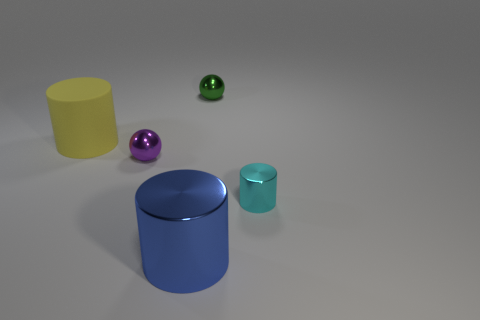Subtract all large cylinders. How many cylinders are left? 1 Add 2 large blue metallic things. How many objects exist? 7 Subtract all spheres. How many objects are left? 3 Subtract all yellow balls. Subtract all small green metallic balls. How many objects are left? 4 Add 5 cyan metallic things. How many cyan metallic things are left? 6 Add 5 cyan rubber spheres. How many cyan rubber spheres exist? 5 Subtract 0 purple blocks. How many objects are left? 5 